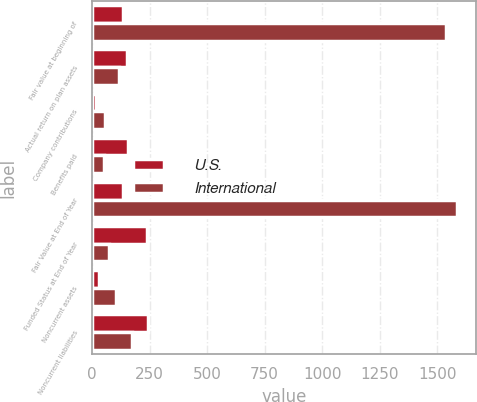Convert chart. <chart><loc_0><loc_0><loc_500><loc_500><stacked_bar_chart><ecel><fcel>Fair value at beginning of<fcel>Actual return on plan assets<fcel>Company contributions<fcel>Benefits paid<fcel>Fair Value at End of Year<fcel>Funded Status at End of Year<fcel>Noncurrent assets<fcel>Noncurrent liabilities<nl><fcel>U.S.<fcel>132.85<fcel>150.2<fcel>14.6<fcel>157.3<fcel>132.85<fcel>237.9<fcel>28.2<fcel>242.6<nl><fcel>International<fcel>1540<fcel>115.5<fcel>53.7<fcel>51.3<fcel>1588.2<fcel>72.3<fcel>103.5<fcel>174.6<nl></chart> 